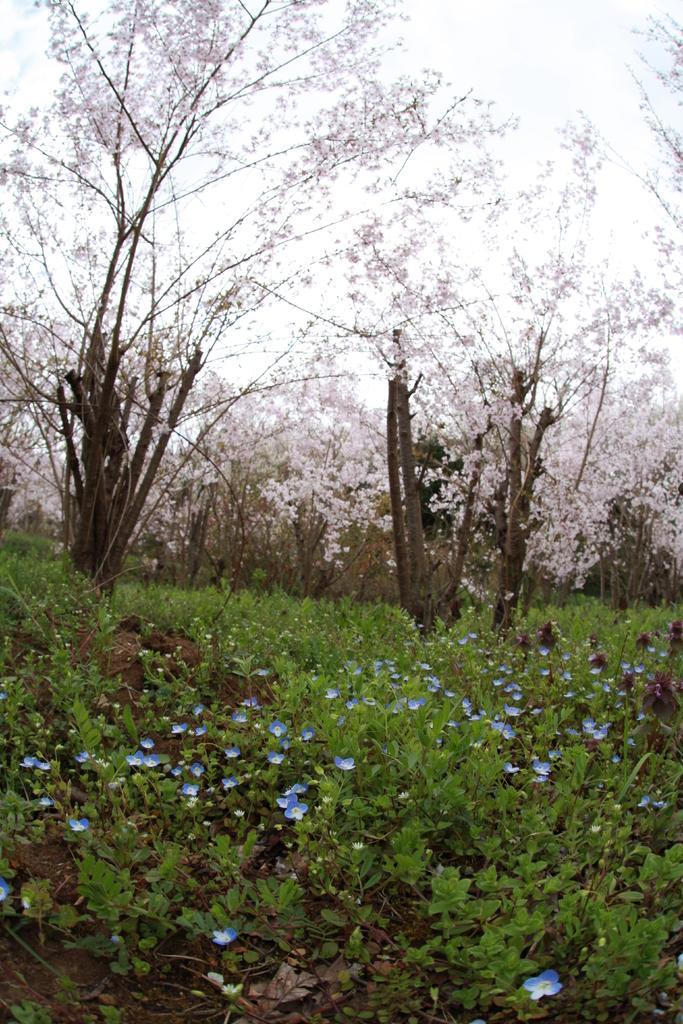How would you summarize this image in a sentence or two? This picture is clicked outside. In the foreground we can see the plants and the flowers. In the background we can see the sky and the trees. 